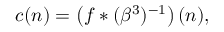<formula> <loc_0><loc_0><loc_500><loc_500>c ( n ) = \left ( f * ( \beta ^ { 3 } ) ^ { - 1 } \right ) ( n ) ,</formula> 